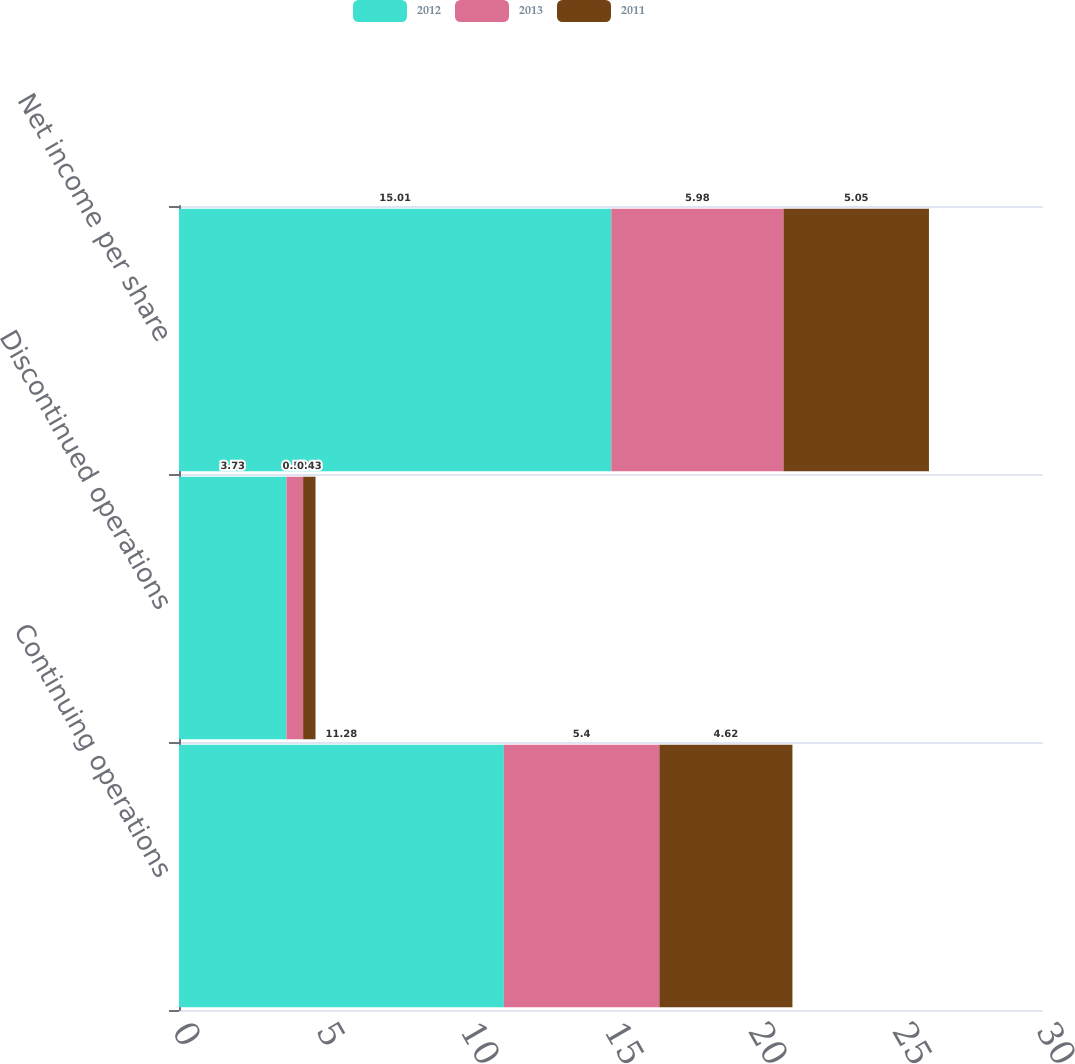<chart> <loc_0><loc_0><loc_500><loc_500><stacked_bar_chart><ecel><fcel>Continuing operations<fcel>Discontinued operations<fcel>Net income per share<nl><fcel>2012<fcel>11.28<fcel>3.73<fcel>15.01<nl><fcel>2013<fcel>5.4<fcel>0.58<fcel>5.98<nl><fcel>2011<fcel>4.62<fcel>0.43<fcel>5.05<nl></chart> 